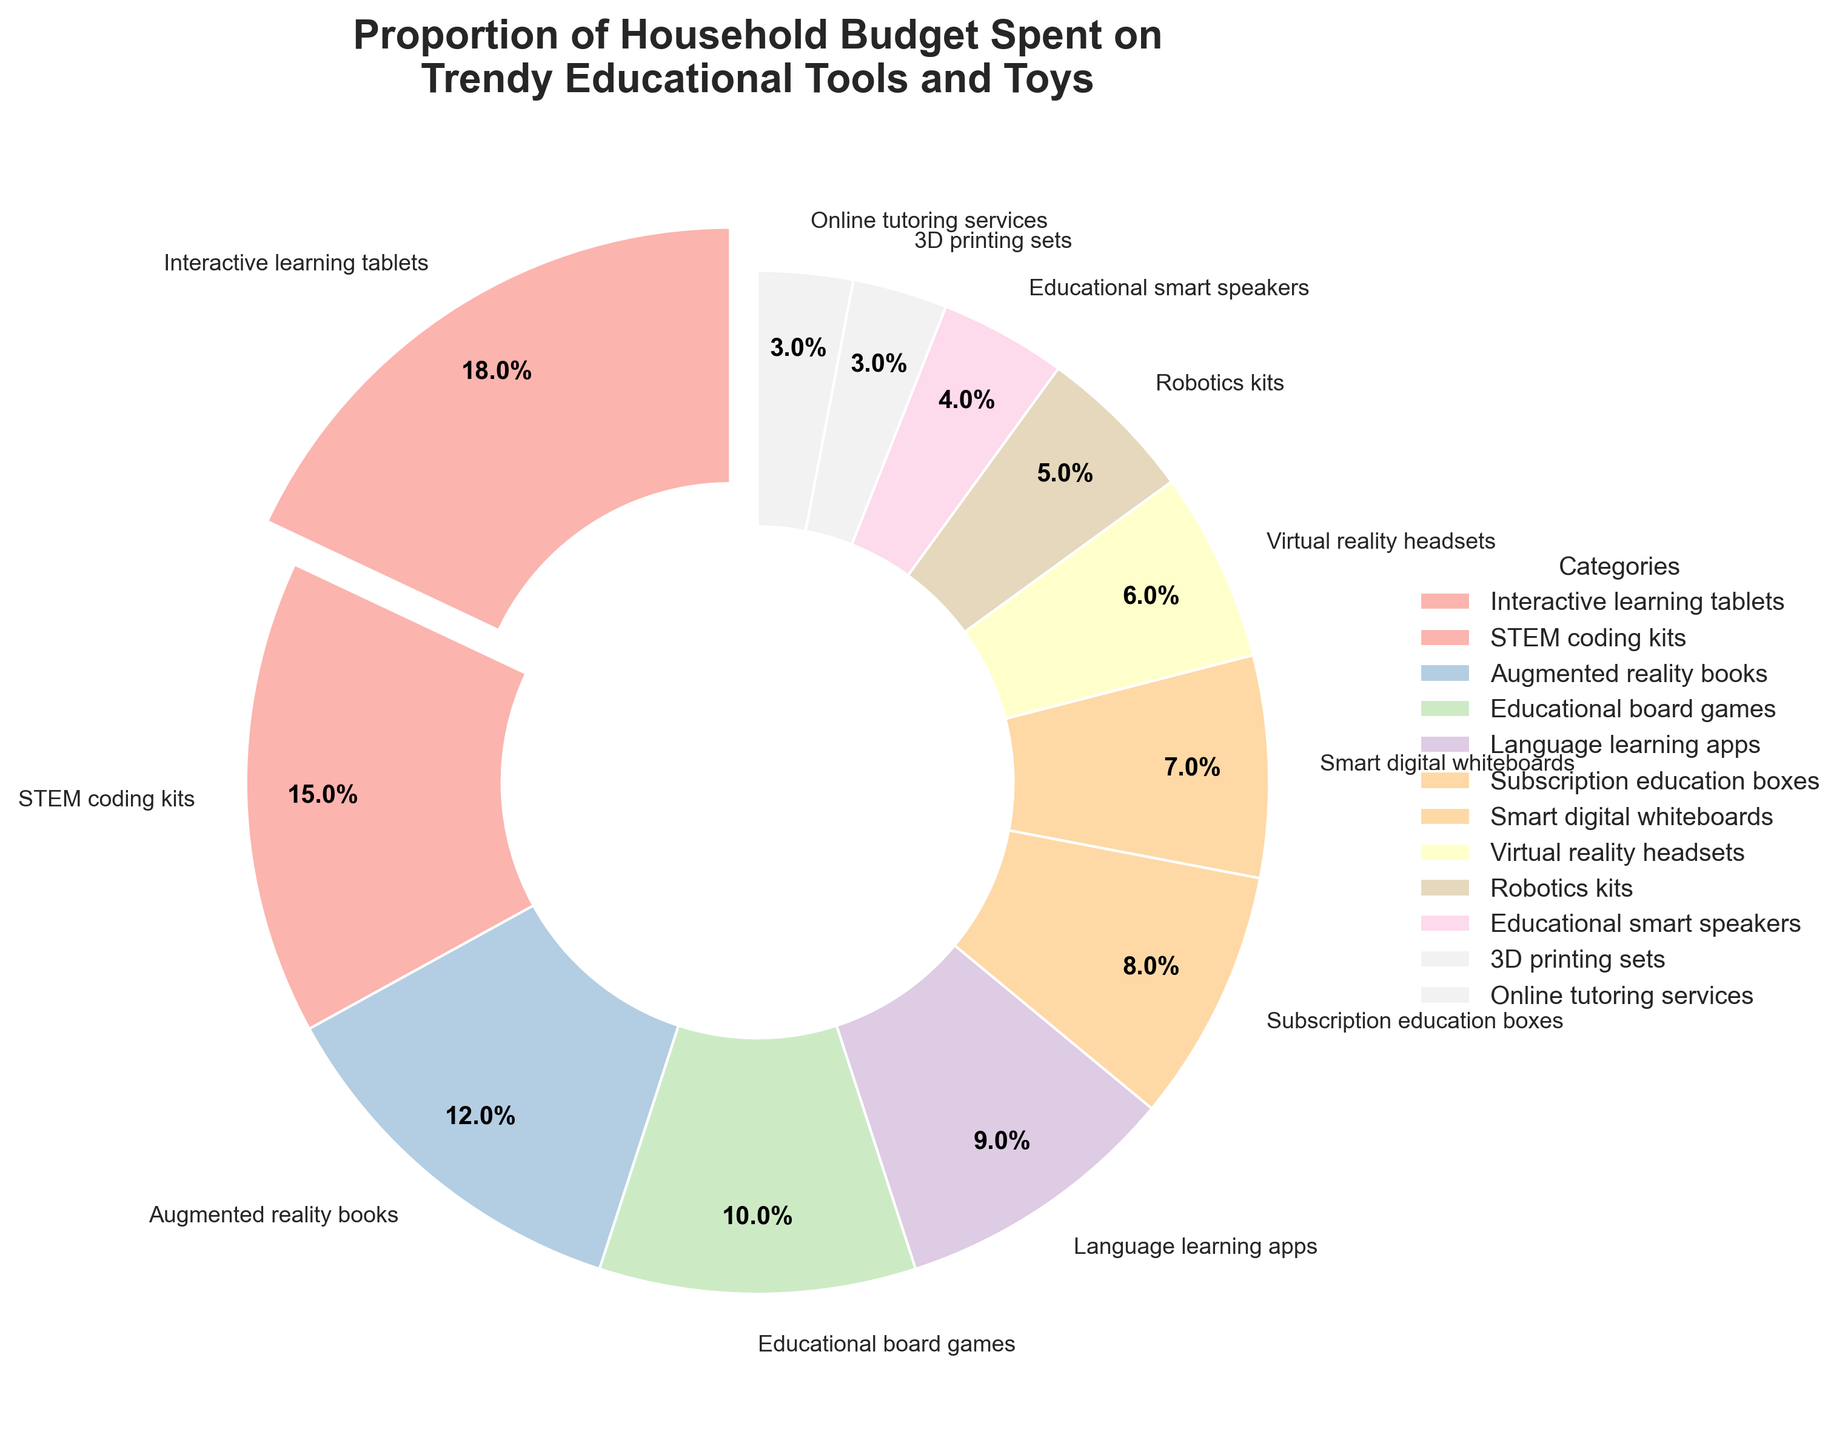Which category has the highest spending proportion? The category with the highest spending proportion can be identified from the exploded wedge in the pie chart. The wedge for "Interactive learning tablets" is slightly separated from the rest and represents 18% of the budget, the highest percentage.
Answer: Interactive learning tablets How much more is spent on Interactive learning tablets than on Educational smart speakers? The percentage spent on Interactive learning tablets is 18%, while that on Educational smart speakers is 4%. The difference can be calculated as 18% - 4%.
Answer: 14% What is the total spending percentage on Language learning apps, Subscription education boxes, and Online tutoring services combined? To find the total, sum the percentages of the three mentioned categories: 9% (Language learning apps) + 8% (Subscription education boxes) + 3% (Online tutoring services).
Answer: 20% Which has a higher proportion of spending: STEM coding kits or Virtual reality headsets? By comparing their percentages, STEM coding kits have a spending proportion of 15%, while Virtual reality headsets have 6%. 15% is greater than 6%.
Answer: STEM coding kits Are there more categories with a spending proportion above or below 8%? Count the number of categories with spending percentages above and below 8%. Categories with percentages above 8%: Interactive learning tablets (18%), STEM coding kits (15%), Augmented reality books (12%), Educational board games (10%), Language learning apps (9%) – Total: 5 categories. Categories with percentages below 8%: Subscription education boxes (8%), Smart digital whiteboards (7%), Virtual reality headsets (6%), Robotics kits (5%), Educational smart speakers (4%), 3D printing sets (3%), Online tutoring services (3%) – Total: 7 categories.
Answer: Below What is the average spending percentage on Subscription education boxes, Smart digital whiteboards, and Robotics kits? Calculate the average by summing their percentages and dividing by the number of categories. (8 + 7 + 5) / 3 = (20) / 3.
Answer: Approximately 6.7% Compare the spending proportions between the top three categories. Which category ranks second? The top three categories by percentage are Interactive learning tablets (18%), STEM coding kits (15%), and Augmented reality books (12%). The second highest is STEM coding kits.
Answer: STEM coding kits Which categories collectively account for exactly 10% of the spending when combined? Review the percentages to find a combination that sums to 10%. Educational board games alone account for 10%.
Answer: Educational board games What is the difference in budget allocation between Augmented reality books and 3D printing sets? Calculate the difference between their percentages: 12% (Augmented reality books) - 3% (3D printing sets).
Answer: 9% 